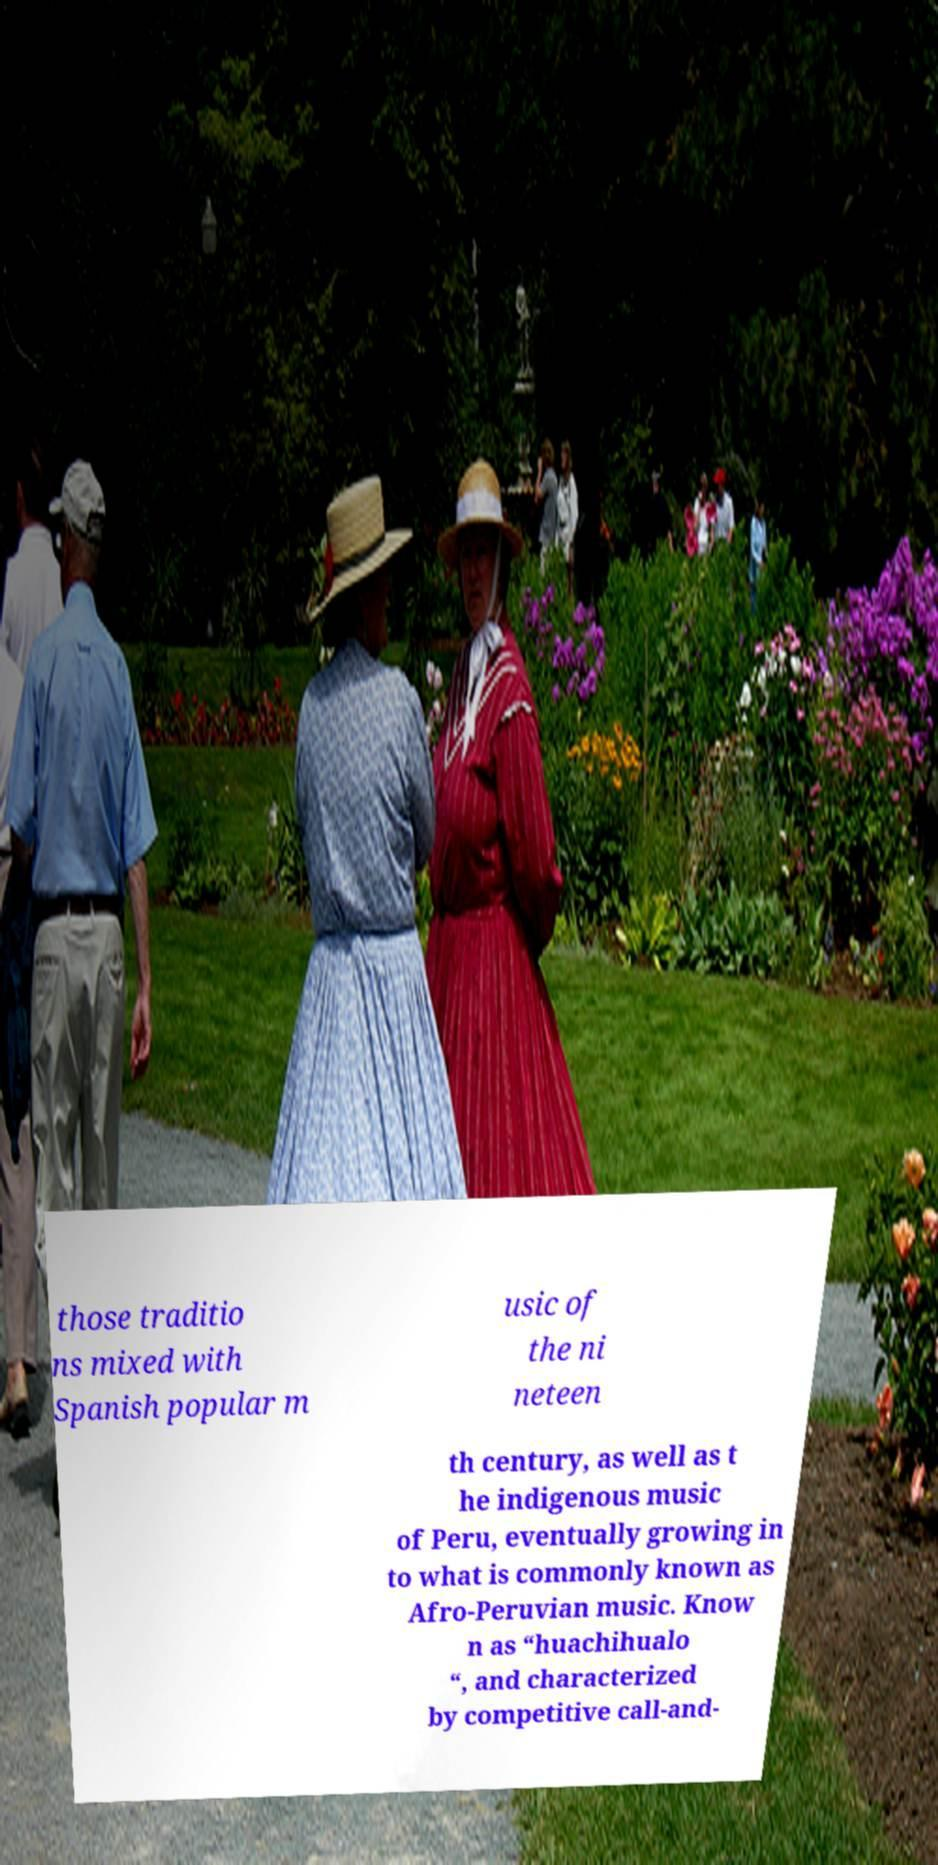Please read and relay the text visible in this image. What does it say? those traditio ns mixed with Spanish popular m usic of the ni neteen th century, as well as t he indigenous music of Peru, eventually growing in to what is commonly known as Afro-Peruvian music. Know n as “huachihualo “, and characterized by competitive call-and- 